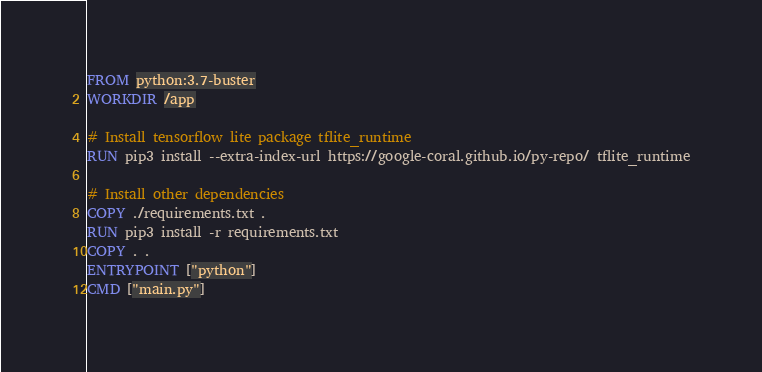<code> <loc_0><loc_0><loc_500><loc_500><_Dockerfile_>FROM python:3.7-buster
WORKDIR /app

# Install tensorflow lite package tflite_runtime
RUN pip3 install --extra-index-url https://google-coral.github.io/py-repo/ tflite_runtime

# Install other dependencies
COPY ./requirements.txt .
RUN pip3 install -r requirements.txt
COPY . .
ENTRYPOINT ["python"]
CMD ["main.py"]
</code> 